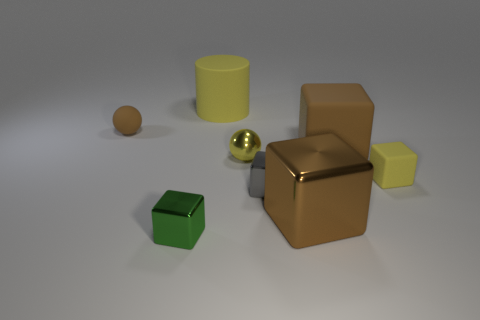Subtract all yellow matte cubes. How many cubes are left? 4 Subtract all yellow blocks. How many blocks are left? 4 Subtract 3 blocks. How many blocks are left? 2 Subtract all red cubes. Subtract all blue cylinders. How many cubes are left? 5 Add 1 gray objects. How many objects exist? 9 Subtract all cubes. How many objects are left? 3 Add 6 green blocks. How many green blocks are left? 7 Add 5 gray metal things. How many gray metal things exist? 6 Subtract 0 red cubes. How many objects are left? 8 Subtract all cylinders. Subtract all brown metal cubes. How many objects are left? 6 